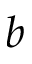Convert formula to latex. <formula><loc_0><loc_0><loc_500><loc_500>b</formula> 